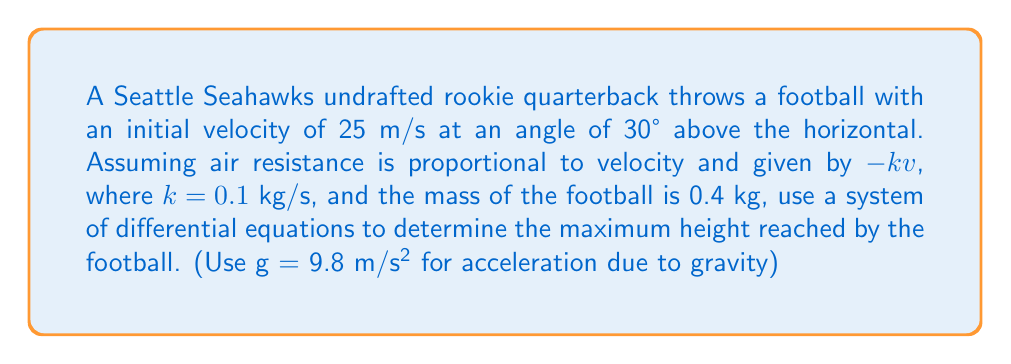Help me with this question. 1) First, let's set up our system of differential equations. We'll use x for horizontal position and y for vertical position:

   $$\frac{d^2x}{dt^2} = -\frac{k}{m}\frac{dx}{dt}$$
   $$\frac{d^2y}{dt^2} = -g - \frac{k}{m}\frac{dy}{dt}$$

2) We can split these into first-order equations:

   $$\frac{dx}{dt} = v_x$$
   $$\frac{dv_x}{dt} = -\frac{k}{m}v_x$$
   $$\frac{dy}{dt} = v_y$$
   $$\frac{dv_y}{dt} = -g - \frac{k}{m}v_y$$

3) Initial conditions:
   $v_x(0) = v_0 \cos\theta = 25 \cos 30° \approx 21.65$ m/s
   $v_y(0) = v_0 \sin\theta = 25 \sin 30° = 12.5$ m/s

4) To find the maximum height, we need to find when $v_y = 0$. The solution for $v_y$ is:

   $$v_y(t) = (v_0 \sin\theta + \frac{mg}{k})e^{-\frac{k}{m}t} - \frac{mg}{k}$$

5) Set this equal to zero and solve for t:

   $$(12.5 + \frac{0.4 \cdot 9.8}{0.1})e^{-\frac{0.1}{0.4}t} - \frac{0.4 \cdot 9.8}{0.1} = 0$$
   
   $$51.7e^{-0.25t} = 39.2$$
   
   $$e^{-0.25t} = \frac{39.2}{51.7}$$
   
   $$t = -4 \ln(\frac{39.2}{51.7}) \approx 1.11$ s

6) Now we can find y(t) by integrating $v_y$:

   $$y(t) = -\frac{m}{k}(v_0 \sin\theta + \frac{mg}{k})(e^{-\frac{k}{m}t} - 1) - \frac{mg}{k}t + C$$

7) Substitute t = 1.11 to find the maximum height:

   $$y_{max} = -4(12.5 + 39.2)(e^{-0.25 \cdot 1.11} - 1) - 39.2 \cdot 1.11 + 0$$
   
   $$y_{max} \approx 4.77$ m
Answer: 4.77 m 